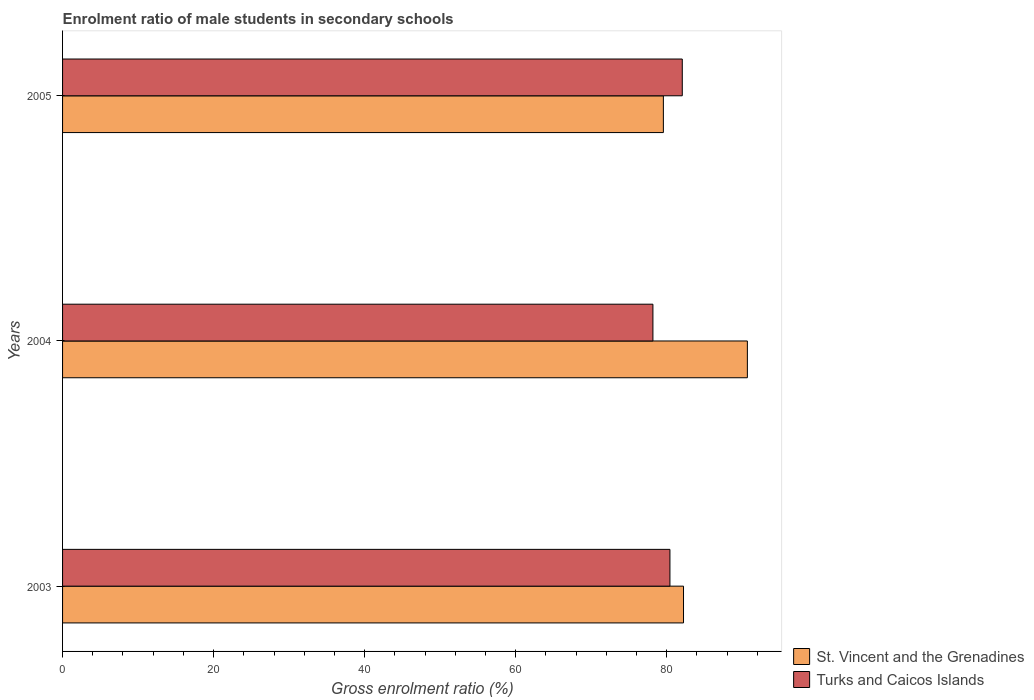How many different coloured bars are there?
Your response must be concise. 2. Are the number of bars per tick equal to the number of legend labels?
Make the answer very short. Yes. Are the number of bars on each tick of the Y-axis equal?
Ensure brevity in your answer.  Yes. How many bars are there on the 1st tick from the top?
Your response must be concise. 2. In how many cases, is the number of bars for a given year not equal to the number of legend labels?
Provide a succinct answer. 0. What is the enrolment ratio of male students in secondary schools in St. Vincent and the Grenadines in 2003?
Offer a very short reply. 82.22. Across all years, what is the maximum enrolment ratio of male students in secondary schools in St. Vincent and the Grenadines?
Provide a short and direct response. 90.68. Across all years, what is the minimum enrolment ratio of male students in secondary schools in Turks and Caicos Islands?
Provide a short and direct response. 78.17. In which year was the enrolment ratio of male students in secondary schools in St. Vincent and the Grenadines minimum?
Provide a short and direct response. 2005. What is the total enrolment ratio of male students in secondary schools in St. Vincent and the Grenadines in the graph?
Give a very brief answer. 252.45. What is the difference between the enrolment ratio of male students in secondary schools in St. Vincent and the Grenadines in 2003 and that in 2005?
Provide a short and direct response. 2.67. What is the difference between the enrolment ratio of male students in secondary schools in St. Vincent and the Grenadines in 2004 and the enrolment ratio of male students in secondary schools in Turks and Caicos Islands in 2003?
Provide a short and direct response. 10.25. What is the average enrolment ratio of male students in secondary schools in Turks and Caicos Islands per year?
Offer a very short reply. 80.22. In the year 2004, what is the difference between the enrolment ratio of male students in secondary schools in Turks and Caicos Islands and enrolment ratio of male students in secondary schools in St. Vincent and the Grenadines?
Your answer should be very brief. -12.51. In how many years, is the enrolment ratio of male students in secondary schools in Turks and Caicos Islands greater than 64 %?
Offer a very short reply. 3. What is the ratio of the enrolment ratio of male students in secondary schools in St. Vincent and the Grenadines in 2003 to that in 2004?
Offer a terse response. 0.91. Is the difference between the enrolment ratio of male students in secondary schools in Turks and Caicos Islands in 2003 and 2004 greater than the difference between the enrolment ratio of male students in secondary schools in St. Vincent and the Grenadines in 2003 and 2004?
Your response must be concise. Yes. What is the difference between the highest and the second highest enrolment ratio of male students in secondary schools in St. Vincent and the Grenadines?
Provide a short and direct response. 8.46. What is the difference between the highest and the lowest enrolment ratio of male students in secondary schools in St. Vincent and the Grenadines?
Offer a very short reply. 11.12. In how many years, is the enrolment ratio of male students in secondary schools in Turks and Caicos Islands greater than the average enrolment ratio of male students in secondary schools in Turks and Caicos Islands taken over all years?
Provide a short and direct response. 2. Is the sum of the enrolment ratio of male students in secondary schools in Turks and Caicos Islands in 2003 and 2004 greater than the maximum enrolment ratio of male students in secondary schools in St. Vincent and the Grenadines across all years?
Ensure brevity in your answer.  Yes. What does the 1st bar from the top in 2003 represents?
Keep it short and to the point. Turks and Caicos Islands. What does the 1st bar from the bottom in 2005 represents?
Offer a very short reply. St. Vincent and the Grenadines. Are all the bars in the graph horizontal?
Your answer should be compact. Yes. How many years are there in the graph?
Give a very brief answer. 3. Are the values on the major ticks of X-axis written in scientific E-notation?
Make the answer very short. No. Does the graph contain any zero values?
Your answer should be compact. No. Where does the legend appear in the graph?
Ensure brevity in your answer.  Bottom right. How many legend labels are there?
Make the answer very short. 2. How are the legend labels stacked?
Give a very brief answer. Vertical. What is the title of the graph?
Offer a very short reply. Enrolment ratio of male students in secondary schools. What is the label or title of the X-axis?
Ensure brevity in your answer.  Gross enrolment ratio (%). What is the label or title of the Y-axis?
Your answer should be compact. Years. What is the Gross enrolment ratio (%) in St. Vincent and the Grenadines in 2003?
Offer a very short reply. 82.22. What is the Gross enrolment ratio (%) in Turks and Caicos Islands in 2003?
Offer a terse response. 80.42. What is the Gross enrolment ratio (%) in St. Vincent and the Grenadines in 2004?
Give a very brief answer. 90.68. What is the Gross enrolment ratio (%) in Turks and Caicos Islands in 2004?
Your answer should be compact. 78.17. What is the Gross enrolment ratio (%) in St. Vincent and the Grenadines in 2005?
Your response must be concise. 79.55. What is the Gross enrolment ratio (%) in Turks and Caicos Islands in 2005?
Your response must be concise. 82.06. Across all years, what is the maximum Gross enrolment ratio (%) in St. Vincent and the Grenadines?
Keep it short and to the point. 90.68. Across all years, what is the maximum Gross enrolment ratio (%) of Turks and Caicos Islands?
Make the answer very short. 82.06. Across all years, what is the minimum Gross enrolment ratio (%) in St. Vincent and the Grenadines?
Offer a very short reply. 79.55. Across all years, what is the minimum Gross enrolment ratio (%) of Turks and Caicos Islands?
Ensure brevity in your answer.  78.17. What is the total Gross enrolment ratio (%) of St. Vincent and the Grenadines in the graph?
Offer a very short reply. 252.45. What is the total Gross enrolment ratio (%) of Turks and Caicos Islands in the graph?
Ensure brevity in your answer.  240.65. What is the difference between the Gross enrolment ratio (%) in St. Vincent and the Grenadines in 2003 and that in 2004?
Offer a terse response. -8.46. What is the difference between the Gross enrolment ratio (%) of Turks and Caicos Islands in 2003 and that in 2004?
Ensure brevity in your answer.  2.25. What is the difference between the Gross enrolment ratio (%) in St. Vincent and the Grenadines in 2003 and that in 2005?
Give a very brief answer. 2.67. What is the difference between the Gross enrolment ratio (%) of Turks and Caicos Islands in 2003 and that in 2005?
Offer a very short reply. -1.63. What is the difference between the Gross enrolment ratio (%) in St. Vincent and the Grenadines in 2004 and that in 2005?
Your response must be concise. 11.12. What is the difference between the Gross enrolment ratio (%) in Turks and Caicos Islands in 2004 and that in 2005?
Your response must be concise. -3.89. What is the difference between the Gross enrolment ratio (%) in St. Vincent and the Grenadines in 2003 and the Gross enrolment ratio (%) in Turks and Caicos Islands in 2004?
Provide a succinct answer. 4.05. What is the difference between the Gross enrolment ratio (%) in St. Vincent and the Grenadines in 2003 and the Gross enrolment ratio (%) in Turks and Caicos Islands in 2005?
Ensure brevity in your answer.  0.16. What is the difference between the Gross enrolment ratio (%) of St. Vincent and the Grenadines in 2004 and the Gross enrolment ratio (%) of Turks and Caicos Islands in 2005?
Offer a very short reply. 8.62. What is the average Gross enrolment ratio (%) of St. Vincent and the Grenadines per year?
Keep it short and to the point. 84.15. What is the average Gross enrolment ratio (%) in Turks and Caicos Islands per year?
Your answer should be compact. 80.22. In the year 2003, what is the difference between the Gross enrolment ratio (%) in St. Vincent and the Grenadines and Gross enrolment ratio (%) in Turks and Caicos Islands?
Make the answer very short. 1.8. In the year 2004, what is the difference between the Gross enrolment ratio (%) in St. Vincent and the Grenadines and Gross enrolment ratio (%) in Turks and Caicos Islands?
Make the answer very short. 12.51. In the year 2005, what is the difference between the Gross enrolment ratio (%) in St. Vincent and the Grenadines and Gross enrolment ratio (%) in Turks and Caicos Islands?
Give a very brief answer. -2.5. What is the ratio of the Gross enrolment ratio (%) in St. Vincent and the Grenadines in 2003 to that in 2004?
Your answer should be very brief. 0.91. What is the ratio of the Gross enrolment ratio (%) of Turks and Caicos Islands in 2003 to that in 2004?
Your answer should be compact. 1.03. What is the ratio of the Gross enrolment ratio (%) of St. Vincent and the Grenadines in 2003 to that in 2005?
Keep it short and to the point. 1.03. What is the ratio of the Gross enrolment ratio (%) of Turks and Caicos Islands in 2003 to that in 2005?
Your answer should be compact. 0.98. What is the ratio of the Gross enrolment ratio (%) of St. Vincent and the Grenadines in 2004 to that in 2005?
Give a very brief answer. 1.14. What is the ratio of the Gross enrolment ratio (%) in Turks and Caicos Islands in 2004 to that in 2005?
Your answer should be compact. 0.95. What is the difference between the highest and the second highest Gross enrolment ratio (%) in St. Vincent and the Grenadines?
Make the answer very short. 8.46. What is the difference between the highest and the second highest Gross enrolment ratio (%) of Turks and Caicos Islands?
Offer a terse response. 1.63. What is the difference between the highest and the lowest Gross enrolment ratio (%) in St. Vincent and the Grenadines?
Provide a succinct answer. 11.12. What is the difference between the highest and the lowest Gross enrolment ratio (%) in Turks and Caicos Islands?
Offer a very short reply. 3.89. 